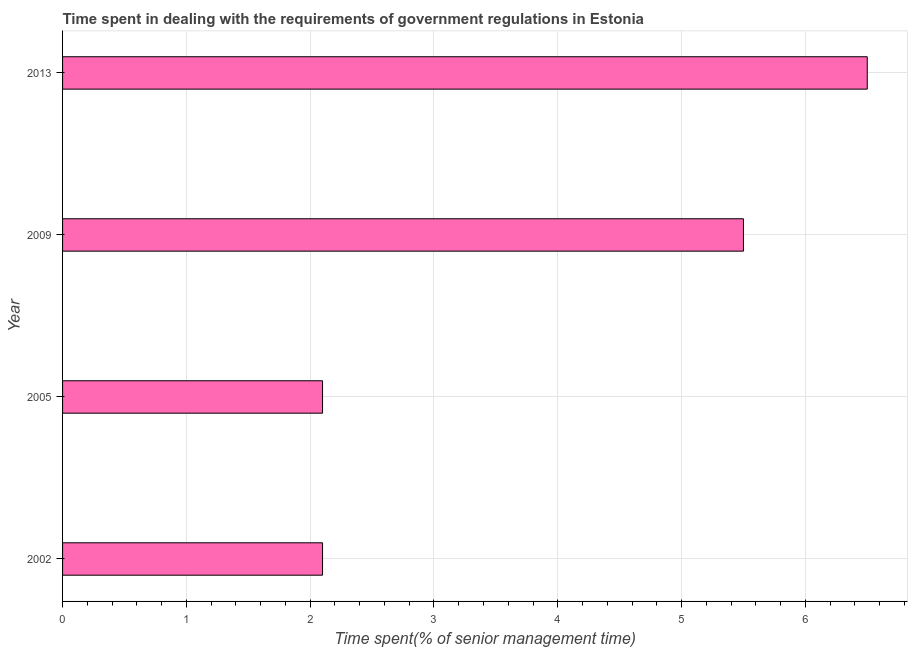Does the graph contain any zero values?
Your answer should be compact. No. What is the title of the graph?
Your answer should be compact. Time spent in dealing with the requirements of government regulations in Estonia. What is the label or title of the X-axis?
Provide a succinct answer. Time spent(% of senior management time). What is the label or title of the Y-axis?
Give a very brief answer. Year. What is the time spent in dealing with government regulations in 2013?
Offer a terse response. 6.5. Across all years, what is the maximum time spent in dealing with government regulations?
Provide a short and direct response. 6.5. Across all years, what is the minimum time spent in dealing with government regulations?
Provide a short and direct response. 2.1. In which year was the time spent in dealing with government regulations maximum?
Make the answer very short. 2013. What is the difference between the time spent in dealing with government regulations in 2002 and 2013?
Provide a succinct answer. -4.4. What is the average time spent in dealing with government regulations per year?
Offer a terse response. 4.05. What is the median time spent in dealing with government regulations?
Offer a very short reply. 3.8. In how many years, is the time spent in dealing with government regulations greater than 2.4 %?
Make the answer very short. 2. What is the ratio of the time spent in dealing with government regulations in 2009 to that in 2013?
Offer a terse response. 0.85. Is the time spent in dealing with government regulations in 2002 less than that in 2009?
Your answer should be compact. Yes. Is the difference between the time spent in dealing with government regulations in 2005 and 2009 greater than the difference between any two years?
Give a very brief answer. No. Is the sum of the time spent in dealing with government regulations in 2005 and 2009 greater than the maximum time spent in dealing with government regulations across all years?
Your response must be concise. Yes. What is the difference between the highest and the lowest time spent in dealing with government regulations?
Your answer should be compact. 4.4. In how many years, is the time spent in dealing with government regulations greater than the average time spent in dealing with government regulations taken over all years?
Ensure brevity in your answer.  2. Are all the bars in the graph horizontal?
Give a very brief answer. Yes. How many years are there in the graph?
Provide a succinct answer. 4. What is the difference between two consecutive major ticks on the X-axis?
Ensure brevity in your answer.  1. Are the values on the major ticks of X-axis written in scientific E-notation?
Your answer should be very brief. No. What is the Time spent(% of senior management time) in 2005?
Offer a very short reply. 2.1. What is the Time spent(% of senior management time) of 2013?
Ensure brevity in your answer.  6.5. What is the difference between the Time spent(% of senior management time) in 2002 and 2009?
Provide a short and direct response. -3.4. What is the ratio of the Time spent(% of senior management time) in 2002 to that in 2005?
Your answer should be very brief. 1. What is the ratio of the Time spent(% of senior management time) in 2002 to that in 2009?
Provide a short and direct response. 0.38. What is the ratio of the Time spent(% of senior management time) in 2002 to that in 2013?
Make the answer very short. 0.32. What is the ratio of the Time spent(% of senior management time) in 2005 to that in 2009?
Offer a terse response. 0.38. What is the ratio of the Time spent(% of senior management time) in 2005 to that in 2013?
Provide a succinct answer. 0.32. What is the ratio of the Time spent(% of senior management time) in 2009 to that in 2013?
Your answer should be compact. 0.85. 